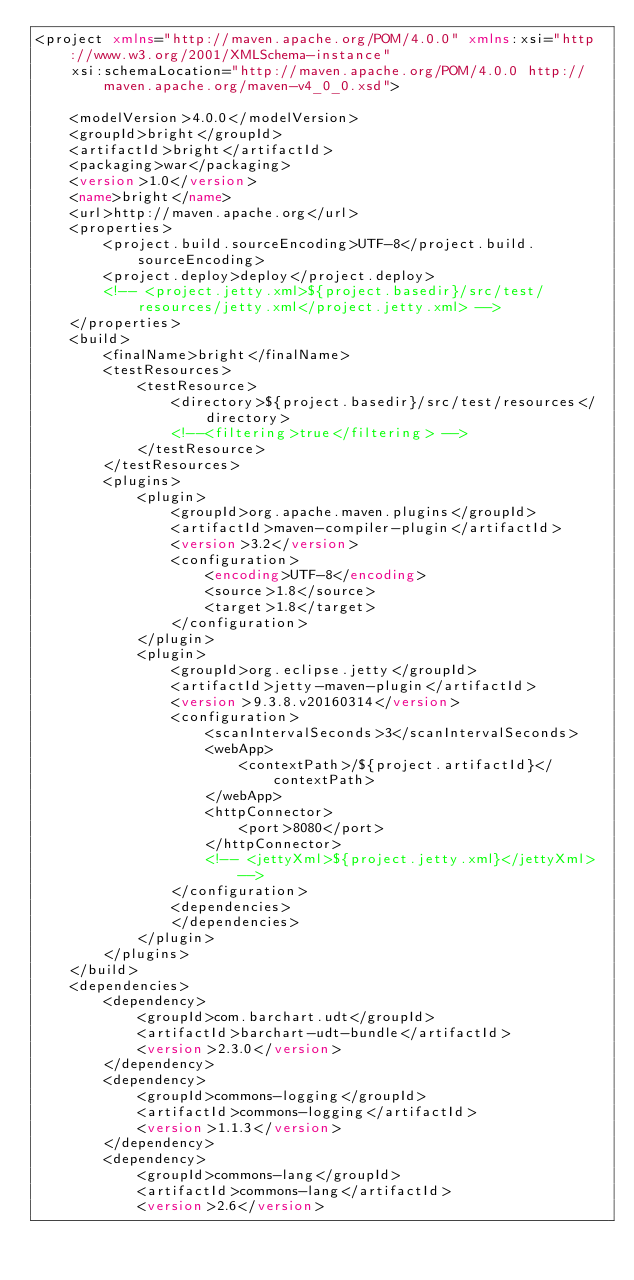<code> <loc_0><loc_0><loc_500><loc_500><_XML_><project xmlns="http://maven.apache.org/POM/4.0.0" xmlns:xsi="http://www.w3.org/2001/XMLSchema-instance"
	xsi:schemaLocation="http://maven.apache.org/POM/4.0.0 http://maven.apache.org/maven-v4_0_0.xsd">

	<modelVersion>4.0.0</modelVersion>
	<groupId>bright</groupId>
	<artifactId>bright</artifactId>
	<packaging>war</packaging>
	<version>1.0</version>
	<name>bright</name>
	<url>http://maven.apache.org</url>
	<properties>
		<project.build.sourceEncoding>UTF-8</project.build.sourceEncoding>
		<project.deploy>deploy</project.deploy>
		<!-- <project.jetty.xml>${project.basedir}/src/test/resources/jetty.xml</project.jetty.xml> -->
	</properties>
	<build>
		<finalName>bright</finalName>
		<testResources>
			<testResource>
				<directory>${project.basedir}/src/test/resources</directory>
				<!--<filtering>true</filtering> -->
			</testResource>
		</testResources>
		<plugins>
			<plugin>
				<groupId>org.apache.maven.plugins</groupId>
				<artifactId>maven-compiler-plugin</artifactId>
				<version>3.2</version>
				<configuration>
					<encoding>UTF-8</encoding>
					<source>1.8</source>
					<target>1.8</target>
				</configuration>
			</plugin>
			<plugin>
				<groupId>org.eclipse.jetty</groupId>
				<artifactId>jetty-maven-plugin</artifactId>
				<version>9.3.8.v20160314</version>
				<configuration>
					<scanIntervalSeconds>3</scanIntervalSeconds>
					<webApp>
						<contextPath>/${project.artifactId}</contextPath>
					</webApp>
					<httpConnector>
						<port>8080</port>
					</httpConnector>
					<!-- <jettyXml>${project.jetty.xml}</jettyXml> -->
				</configuration>
				<dependencies>
				</dependencies>
			</plugin>
		</plugins>
	</build>
	<dependencies>
		<dependency>
			<groupId>com.barchart.udt</groupId>
			<artifactId>barchart-udt-bundle</artifactId>
			<version>2.3.0</version>
		</dependency>
		<dependency>
			<groupId>commons-logging</groupId>
			<artifactId>commons-logging</artifactId>
			<version>1.1.3</version>
		</dependency>
		<dependency>
			<groupId>commons-lang</groupId>
			<artifactId>commons-lang</artifactId>
			<version>2.6</version></code> 